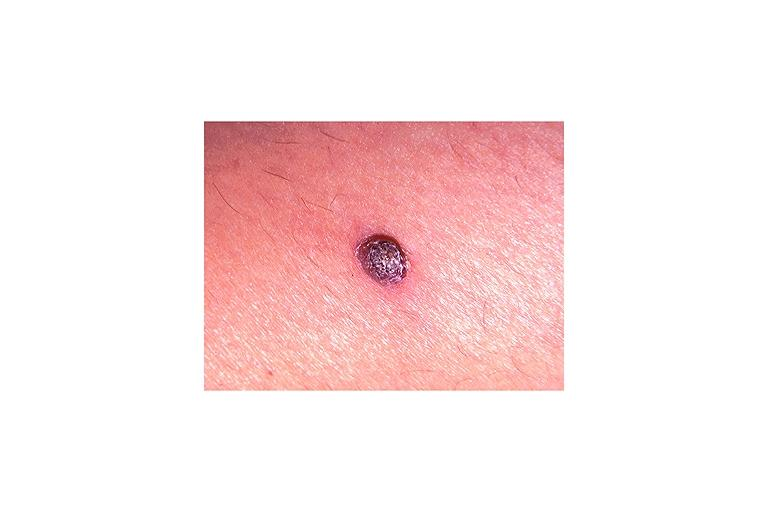where is this?
Answer the question using a single word or phrase. Skin 